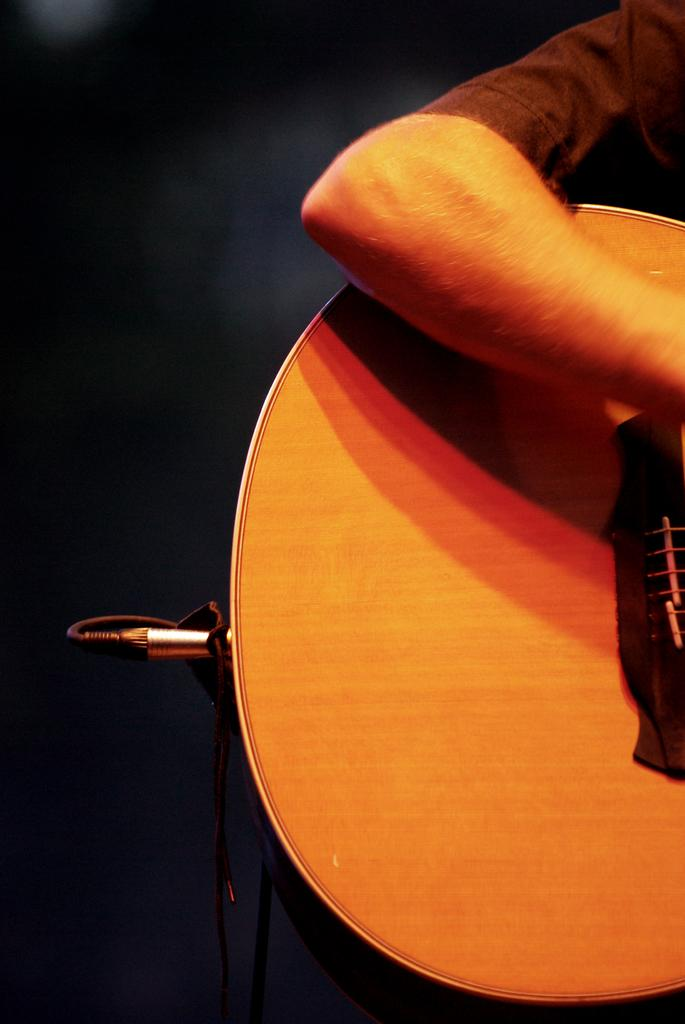What is the main subject of the image? There is a person in the image. What is the person holding in the image? The person is holding a guitar. Can you describe the guitar in more detail? The guitar has wires inserted in it. What type of spot can be seen on the person's shirt in the image? There is no mention of a spot on the person's shirt in the provided facts, so we cannot answer that question. 